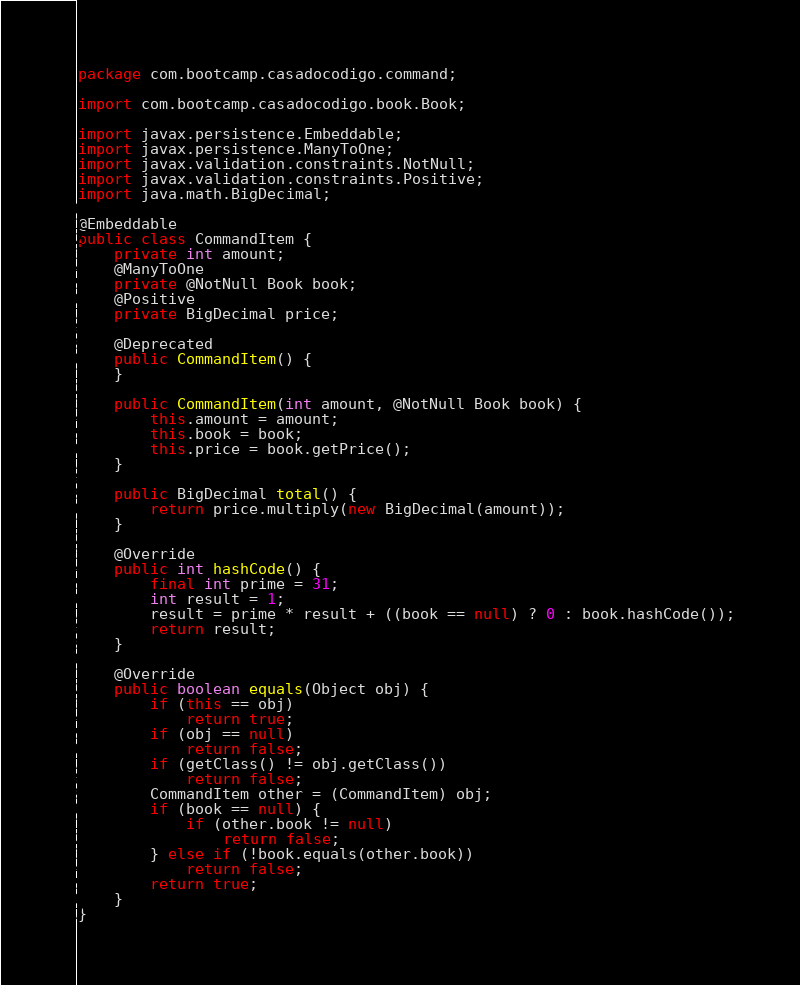Convert code to text. <code><loc_0><loc_0><loc_500><loc_500><_Java_>package com.bootcamp.casadocodigo.command;

import com.bootcamp.casadocodigo.book.Book;

import javax.persistence.Embeddable;
import javax.persistence.ManyToOne;
import javax.validation.constraints.NotNull;
import javax.validation.constraints.Positive;
import java.math.BigDecimal;

@Embeddable
public class CommandItem {
    private int amount;
    @ManyToOne
    private @NotNull Book book;
    @Positive
    private BigDecimal price;

    @Deprecated
    public CommandItem() {
    }

    public CommandItem(int amount, @NotNull Book book) {
        this.amount = amount;
        this.book = book;
        this.price = book.getPrice();
    }

    public BigDecimal total() {
        return price.multiply(new BigDecimal(amount));
    }

    @Override
    public int hashCode() {
        final int prime = 31;
        int result = 1;
        result = prime * result + ((book == null) ? 0 : book.hashCode());
        return result;
    }

    @Override
    public boolean equals(Object obj) {
        if (this == obj)
            return true;
        if (obj == null)
            return false;
        if (getClass() != obj.getClass())
            return false;
        CommandItem other = (CommandItem) obj;
        if (book == null) {
            if (other.book != null)
                return false;
        } else if (!book.equals(other.book))
            return false;
        return true;
    }
}
</code> 